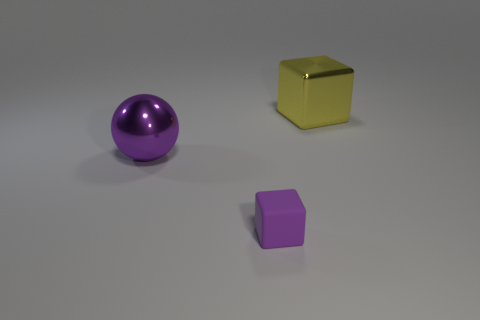What is the color of the other thing that is the same shape as the purple rubber thing?
Ensure brevity in your answer.  Yellow. There is a metallic thing in front of the thing behind the purple metallic object; what is its size?
Give a very brief answer. Large. Is there any other thing that has the same shape as the large purple object?
Your response must be concise. No. Are there fewer tiny metal cylinders than big purple shiny objects?
Your response must be concise. Yes. There is a thing that is to the right of the big metal ball and behind the tiny purple cube; what is its material?
Make the answer very short. Metal. Is there a big yellow object left of the shiny object on the left side of the small matte block?
Make the answer very short. No. What number of things are purple objects or large things?
Provide a short and direct response. 3. There is a object that is behind the purple rubber thing and in front of the yellow metal block; what shape is it?
Keep it short and to the point. Sphere. Is the material of the object that is left of the small rubber object the same as the tiny object?
Provide a succinct answer. No. What number of objects are either tiny gray metallic cubes or large things on the left side of the large yellow block?
Provide a succinct answer. 1. 